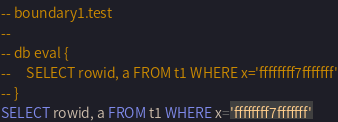<code> <loc_0><loc_0><loc_500><loc_500><_SQL_>-- boundary1.test
-- 
-- db eval {
--     SELECT rowid, a FROM t1 WHERE x='ffffffff7fffffff'
-- }
SELECT rowid, a FROM t1 WHERE x='ffffffff7fffffff'</code> 